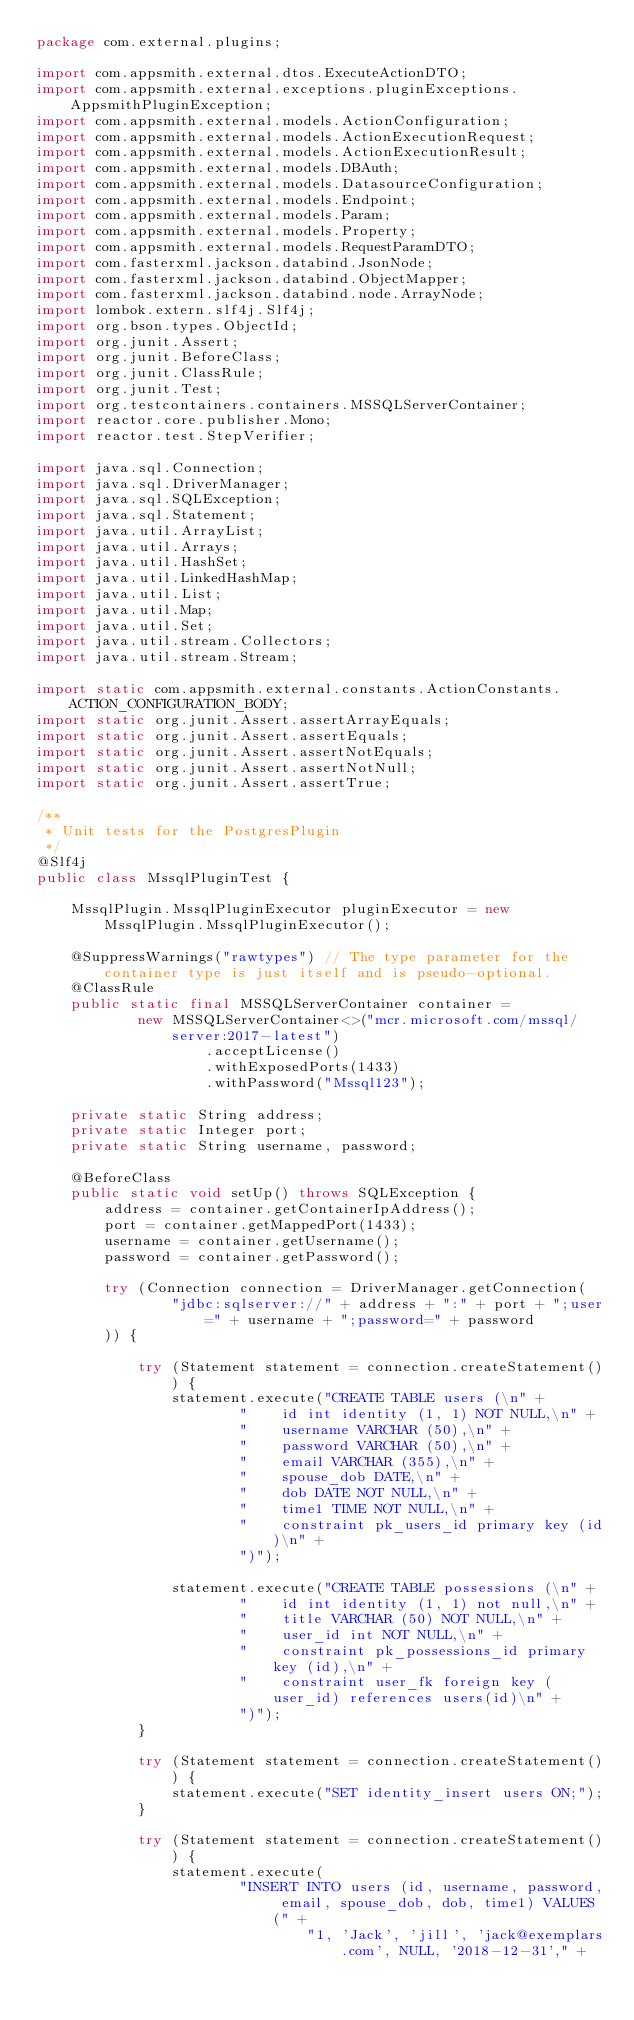<code> <loc_0><loc_0><loc_500><loc_500><_Java_>package com.external.plugins;

import com.appsmith.external.dtos.ExecuteActionDTO;
import com.appsmith.external.exceptions.pluginExceptions.AppsmithPluginException;
import com.appsmith.external.models.ActionConfiguration;
import com.appsmith.external.models.ActionExecutionRequest;
import com.appsmith.external.models.ActionExecutionResult;
import com.appsmith.external.models.DBAuth;
import com.appsmith.external.models.DatasourceConfiguration;
import com.appsmith.external.models.Endpoint;
import com.appsmith.external.models.Param;
import com.appsmith.external.models.Property;
import com.appsmith.external.models.RequestParamDTO;
import com.fasterxml.jackson.databind.JsonNode;
import com.fasterxml.jackson.databind.ObjectMapper;
import com.fasterxml.jackson.databind.node.ArrayNode;
import lombok.extern.slf4j.Slf4j;
import org.bson.types.ObjectId;
import org.junit.Assert;
import org.junit.BeforeClass;
import org.junit.ClassRule;
import org.junit.Test;
import org.testcontainers.containers.MSSQLServerContainer;
import reactor.core.publisher.Mono;
import reactor.test.StepVerifier;

import java.sql.Connection;
import java.sql.DriverManager;
import java.sql.SQLException;
import java.sql.Statement;
import java.util.ArrayList;
import java.util.Arrays;
import java.util.HashSet;
import java.util.LinkedHashMap;
import java.util.List;
import java.util.Map;
import java.util.Set;
import java.util.stream.Collectors;
import java.util.stream.Stream;

import static com.appsmith.external.constants.ActionConstants.ACTION_CONFIGURATION_BODY;
import static org.junit.Assert.assertArrayEquals;
import static org.junit.Assert.assertEquals;
import static org.junit.Assert.assertNotEquals;
import static org.junit.Assert.assertNotNull;
import static org.junit.Assert.assertTrue;

/**
 * Unit tests for the PostgresPlugin
 */
@Slf4j
public class MssqlPluginTest {

    MssqlPlugin.MssqlPluginExecutor pluginExecutor = new MssqlPlugin.MssqlPluginExecutor();

    @SuppressWarnings("rawtypes") // The type parameter for the container type is just itself and is pseudo-optional.
    @ClassRule
    public static final MSSQLServerContainer container =
            new MSSQLServerContainer<>("mcr.microsoft.com/mssql/server:2017-latest")
                    .acceptLicense()
                    .withExposedPorts(1433)
                    .withPassword("Mssql123");

    private static String address;
    private static Integer port;
    private static String username, password;

    @BeforeClass
    public static void setUp() throws SQLException {
        address = container.getContainerIpAddress();
        port = container.getMappedPort(1433);
        username = container.getUsername();
        password = container.getPassword();

        try (Connection connection = DriverManager.getConnection(
                "jdbc:sqlserver://" + address + ":" + port + ";user=" + username + ";password=" + password
        )) {

            try (Statement statement = connection.createStatement()) {
                statement.execute("CREATE TABLE users (\n" +
                        "    id int identity (1, 1) NOT NULL,\n" +
                        "    username VARCHAR (50),\n" +
                        "    password VARCHAR (50),\n" +
                        "    email VARCHAR (355),\n" +
                        "    spouse_dob DATE,\n" +
                        "    dob DATE NOT NULL,\n" +
                        "    time1 TIME NOT NULL,\n" +
                        "    constraint pk_users_id primary key (id)\n" +
                        ")");

                statement.execute("CREATE TABLE possessions (\n" +
                        "    id int identity (1, 1) not null,\n" +
                        "    title VARCHAR (50) NOT NULL,\n" +
                        "    user_id int NOT NULL,\n" +
                        "    constraint pk_possessions_id primary key (id),\n" +
                        "    constraint user_fk foreign key (user_id) references users(id)\n" +
                        ")");
            }

            try (Statement statement = connection.createStatement()) {
                statement.execute("SET identity_insert users ON;");
            }

            try (Statement statement = connection.createStatement()) {
                statement.execute(
                        "INSERT INTO users (id, username, password, email, spouse_dob, dob, time1) VALUES (" +
                                "1, 'Jack', 'jill', 'jack@exemplars.com', NULL, '2018-12-31'," +</code> 